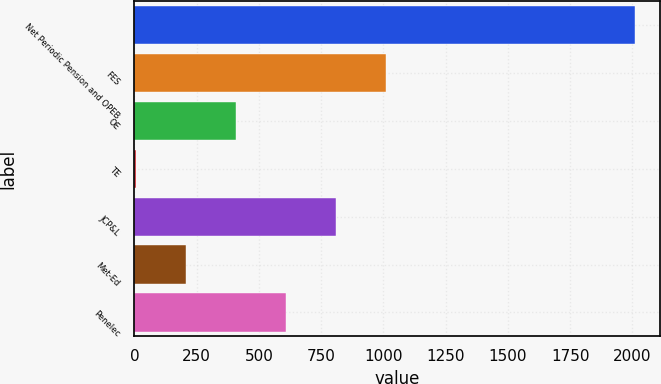Convert chart to OTSL. <chart><loc_0><loc_0><loc_500><loc_500><bar_chart><fcel>Net Periodic Pension and OPEB<fcel>FES<fcel>OE<fcel>TE<fcel>JCP&L<fcel>Met-Ed<fcel>Penelec<nl><fcel>2010<fcel>1008.5<fcel>407.6<fcel>7<fcel>808.2<fcel>207.3<fcel>607.9<nl></chart> 